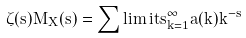<formula> <loc_0><loc_0><loc_500><loc_500>\zeta ( s ) M _ { X } ( s ) = \sum \lim i t s _ { k = 1 } ^ { \infty } a ( k ) k ^ { - s }</formula> 